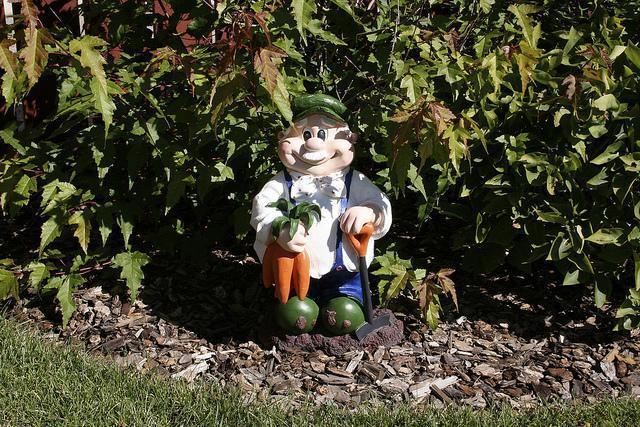How many babies are pictured?
Give a very brief answer. 0. 